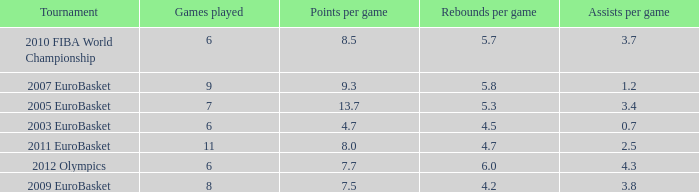How many points per game have the tournament 2005 eurobasket? 13.7. 